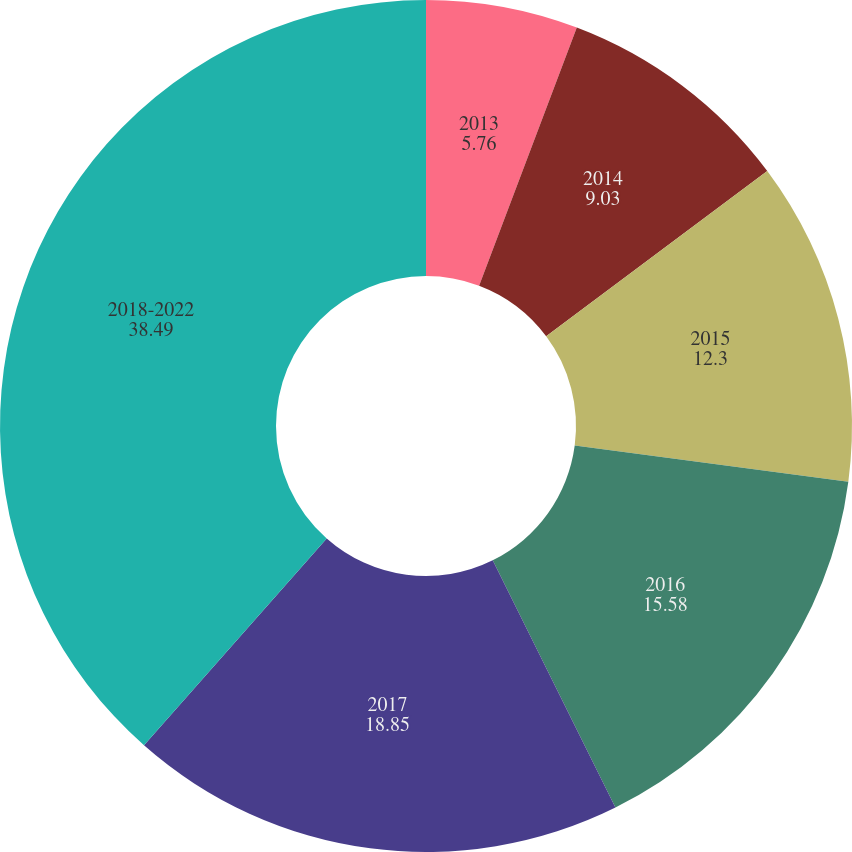Convert chart. <chart><loc_0><loc_0><loc_500><loc_500><pie_chart><fcel>2013<fcel>2014<fcel>2015<fcel>2016<fcel>2017<fcel>2018-2022<nl><fcel>5.76%<fcel>9.03%<fcel>12.3%<fcel>15.58%<fcel>18.85%<fcel>38.49%<nl></chart> 